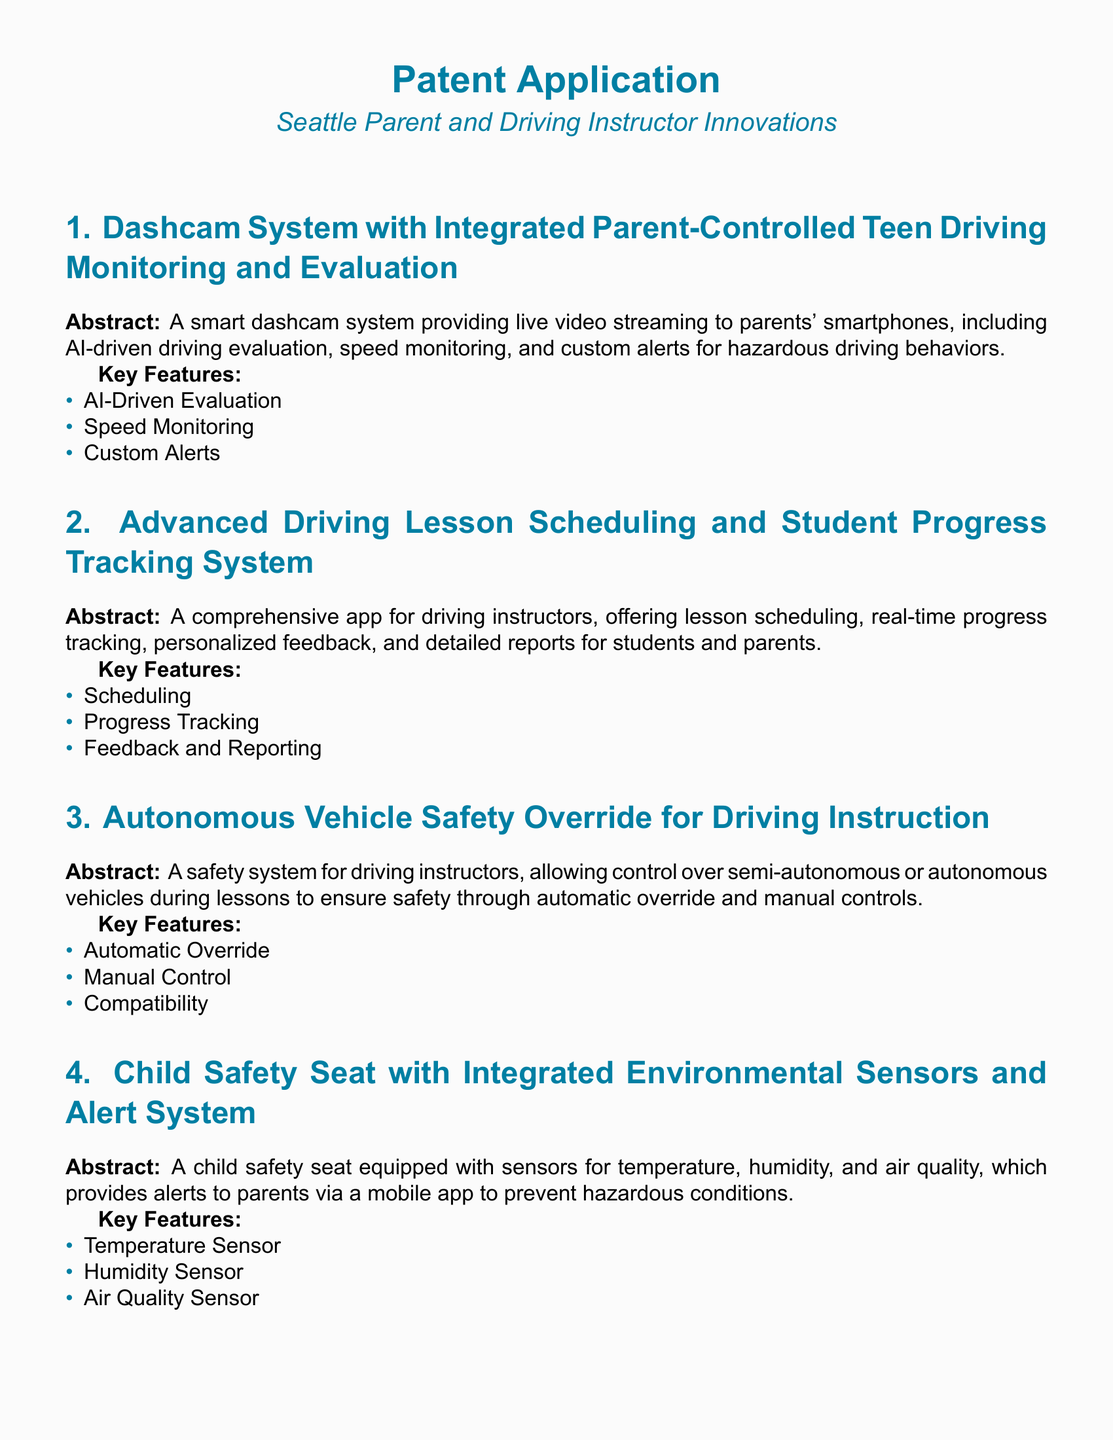What is the main function of the dashcam system? The dashcam system provides live video streaming to parents' smartphones, including AI-driven driving evaluation, speed monitoring, and custom alerts for hazardous driving behaviors.
Answer: Live video streaming What feature allows instructors to manage lesson schedules? The Advanced Driving Lesson Scheduling and Student Progress Tracking System includes lesson scheduling as one of its key features.
Answer: Scheduling Which patent involves a child safety seat? The patent related to a child safety seat is titled "Child Safety Seat with Integrated Environmental Sensors and Alert System."
Answer: Child Safety Seat with Integrated Environmental Sensors and Alert System How does the dashcam system alert parents? The dashcam system includes custom alerts for hazardous driving behaviors.
Answer: Custom alerts What key feature promotes efficient driving practices in the Eco-Friendly Driving Assistant? The Eco-Friendly Driving Assistant provides real-time feedback on fuel consumption, driving habits, and eco-friendly tips.
Answer: Real-Time Fuel Data What does the Autonomous Vehicle Safety Override allow instructors to do? It allows driving instructors to take control over semi-autonomous or autonomous vehicles during lessons.
Answer: Take control What type of information does the child safety seat monitor? The child safety seat is equipped with sensors for temperature, humidity, and air quality.
Answer: Temperature, humidity, air quality What is the overarching aim of the Advanced Driving Lesson Scheduling System? It aims to provide real-time progress tracking and personalized feedback to both instructors and students.
Answer: Real-time progress tracking What is the target audience for the Dashcam System? The target audience for the Dashcam System is parents monitoring teen driving.
Answer: Parents 